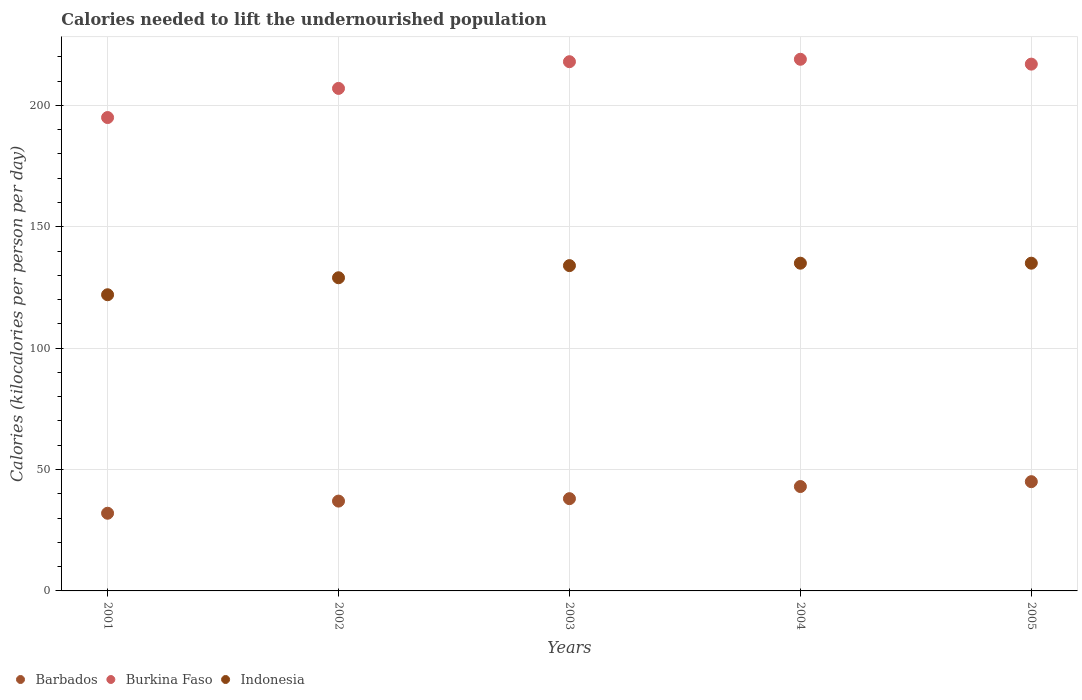Is the number of dotlines equal to the number of legend labels?
Give a very brief answer. Yes. What is the total calories needed to lift the undernourished population in Burkina Faso in 2001?
Provide a short and direct response. 195. Across all years, what is the maximum total calories needed to lift the undernourished population in Burkina Faso?
Offer a very short reply. 219. Across all years, what is the minimum total calories needed to lift the undernourished population in Burkina Faso?
Give a very brief answer. 195. What is the total total calories needed to lift the undernourished population in Indonesia in the graph?
Provide a succinct answer. 655. What is the difference between the total calories needed to lift the undernourished population in Burkina Faso in 2002 and that in 2005?
Make the answer very short. -10. What is the difference between the total calories needed to lift the undernourished population in Indonesia in 2002 and the total calories needed to lift the undernourished population in Barbados in 2005?
Keep it short and to the point. 84. What is the average total calories needed to lift the undernourished population in Barbados per year?
Keep it short and to the point. 39. In the year 2003, what is the difference between the total calories needed to lift the undernourished population in Barbados and total calories needed to lift the undernourished population in Indonesia?
Provide a succinct answer. -96. In how many years, is the total calories needed to lift the undernourished population in Indonesia greater than 60 kilocalories?
Give a very brief answer. 5. What is the ratio of the total calories needed to lift the undernourished population in Indonesia in 2003 to that in 2005?
Ensure brevity in your answer.  0.99. What is the difference between the highest and the second highest total calories needed to lift the undernourished population in Indonesia?
Make the answer very short. 0. What is the difference between the highest and the lowest total calories needed to lift the undernourished population in Indonesia?
Offer a very short reply. 13. Is it the case that in every year, the sum of the total calories needed to lift the undernourished population in Barbados and total calories needed to lift the undernourished population in Burkina Faso  is greater than the total calories needed to lift the undernourished population in Indonesia?
Your answer should be compact. Yes. Is the total calories needed to lift the undernourished population in Burkina Faso strictly greater than the total calories needed to lift the undernourished population in Barbados over the years?
Provide a succinct answer. Yes. Is the total calories needed to lift the undernourished population in Indonesia strictly less than the total calories needed to lift the undernourished population in Barbados over the years?
Offer a very short reply. No. How many dotlines are there?
Keep it short and to the point. 3. How many years are there in the graph?
Offer a terse response. 5. What is the difference between two consecutive major ticks on the Y-axis?
Your response must be concise. 50. Does the graph contain any zero values?
Your response must be concise. No. Does the graph contain grids?
Your answer should be compact. Yes. Where does the legend appear in the graph?
Provide a short and direct response. Bottom left. How are the legend labels stacked?
Make the answer very short. Horizontal. What is the title of the graph?
Offer a terse response. Calories needed to lift the undernourished population. What is the label or title of the X-axis?
Your response must be concise. Years. What is the label or title of the Y-axis?
Keep it short and to the point. Calories (kilocalories per person per day). What is the Calories (kilocalories per person per day) in Barbados in 2001?
Offer a terse response. 32. What is the Calories (kilocalories per person per day) of Burkina Faso in 2001?
Your answer should be very brief. 195. What is the Calories (kilocalories per person per day) of Indonesia in 2001?
Ensure brevity in your answer.  122. What is the Calories (kilocalories per person per day) of Burkina Faso in 2002?
Provide a short and direct response. 207. What is the Calories (kilocalories per person per day) in Indonesia in 2002?
Your answer should be very brief. 129. What is the Calories (kilocalories per person per day) of Barbados in 2003?
Make the answer very short. 38. What is the Calories (kilocalories per person per day) in Burkina Faso in 2003?
Your answer should be very brief. 218. What is the Calories (kilocalories per person per day) of Indonesia in 2003?
Provide a short and direct response. 134. What is the Calories (kilocalories per person per day) in Burkina Faso in 2004?
Your response must be concise. 219. What is the Calories (kilocalories per person per day) of Indonesia in 2004?
Your response must be concise. 135. What is the Calories (kilocalories per person per day) of Barbados in 2005?
Ensure brevity in your answer.  45. What is the Calories (kilocalories per person per day) of Burkina Faso in 2005?
Provide a succinct answer. 217. What is the Calories (kilocalories per person per day) in Indonesia in 2005?
Provide a short and direct response. 135. Across all years, what is the maximum Calories (kilocalories per person per day) in Barbados?
Make the answer very short. 45. Across all years, what is the maximum Calories (kilocalories per person per day) of Burkina Faso?
Your answer should be compact. 219. Across all years, what is the maximum Calories (kilocalories per person per day) of Indonesia?
Your answer should be very brief. 135. Across all years, what is the minimum Calories (kilocalories per person per day) in Burkina Faso?
Your answer should be compact. 195. Across all years, what is the minimum Calories (kilocalories per person per day) in Indonesia?
Offer a terse response. 122. What is the total Calories (kilocalories per person per day) in Barbados in the graph?
Make the answer very short. 195. What is the total Calories (kilocalories per person per day) of Burkina Faso in the graph?
Offer a terse response. 1056. What is the total Calories (kilocalories per person per day) in Indonesia in the graph?
Your response must be concise. 655. What is the difference between the Calories (kilocalories per person per day) of Burkina Faso in 2001 and that in 2002?
Your answer should be very brief. -12. What is the difference between the Calories (kilocalories per person per day) in Indonesia in 2001 and that in 2002?
Your answer should be compact. -7. What is the difference between the Calories (kilocalories per person per day) in Barbados in 2001 and that in 2003?
Offer a very short reply. -6. What is the difference between the Calories (kilocalories per person per day) of Indonesia in 2001 and that in 2003?
Keep it short and to the point. -12. What is the difference between the Calories (kilocalories per person per day) of Burkina Faso in 2001 and that in 2004?
Give a very brief answer. -24. What is the difference between the Calories (kilocalories per person per day) in Indonesia in 2001 and that in 2004?
Your answer should be very brief. -13. What is the difference between the Calories (kilocalories per person per day) of Indonesia in 2001 and that in 2005?
Provide a short and direct response. -13. What is the difference between the Calories (kilocalories per person per day) in Barbados in 2002 and that in 2003?
Your answer should be very brief. -1. What is the difference between the Calories (kilocalories per person per day) of Burkina Faso in 2002 and that in 2003?
Provide a short and direct response. -11. What is the difference between the Calories (kilocalories per person per day) in Indonesia in 2002 and that in 2003?
Your answer should be compact. -5. What is the difference between the Calories (kilocalories per person per day) of Indonesia in 2002 and that in 2004?
Keep it short and to the point. -6. What is the difference between the Calories (kilocalories per person per day) of Barbados in 2002 and that in 2005?
Ensure brevity in your answer.  -8. What is the difference between the Calories (kilocalories per person per day) in Indonesia in 2002 and that in 2005?
Keep it short and to the point. -6. What is the difference between the Calories (kilocalories per person per day) of Barbados in 2003 and that in 2004?
Your response must be concise. -5. What is the difference between the Calories (kilocalories per person per day) of Indonesia in 2003 and that in 2004?
Your response must be concise. -1. What is the difference between the Calories (kilocalories per person per day) of Barbados in 2004 and that in 2005?
Keep it short and to the point. -2. What is the difference between the Calories (kilocalories per person per day) in Indonesia in 2004 and that in 2005?
Offer a very short reply. 0. What is the difference between the Calories (kilocalories per person per day) of Barbados in 2001 and the Calories (kilocalories per person per day) of Burkina Faso in 2002?
Your answer should be very brief. -175. What is the difference between the Calories (kilocalories per person per day) in Barbados in 2001 and the Calories (kilocalories per person per day) in Indonesia in 2002?
Your response must be concise. -97. What is the difference between the Calories (kilocalories per person per day) of Barbados in 2001 and the Calories (kilocalories per person per day) of Burkina Faso in 2003?
Ensure brevity in your answer.  -186. What is the difference between the Calories (kilocalories per person per day) of Barbados in 2001 and the Calories (kilocalories per person per day) of Indonesia in 2003?
Give a very brief answer. -102. What is the difference between the Calories (kilocalories per person per day) of Barbados in 2001 and the Calories (kilocalories per person per day) of Burkina Faso in 2004?
Give a very brief answer. -187. What is the difference between the Calories (kilocalories per person per day) of Barbados in 2001 and the Calories (kilocalories per person per day) of Indonesia in 2004?
Ensure brevity in your answer.  -103. What is the difference between the Calories (kilocalories per person per day) in Burkina Faso in 2001 and the Calories (kilocalories per person per day) in Indonesia in 2004?
Give a very brief answer. 60. What is the difference between the Calories (kilocalories per person per day) of Barbados in 2001 and the Calories (kilocalories per person per day) of Burkina Faso in 2005?
Keep it short and to the point. -185. What is the difference between the Calories (kilocalories per person per day) of Barbados in 2001 and the Calories (kilocalories per person per day) of Indonesia in 2005?
Make the answer very short. -103. What is the difference between the Calories (kilocalories per person per day) of Burkina Faso in 2001 and the Calories (kilocalories per person per day) of Indonesia in 2005?
Ensure brevity in your answer.  60. What is the difference between the Calories (kilocalories per person per day) in Barbados in 2002 and the Calories (kilocalories per person per day) in Burkina Faso in 2003?
Your answer should be compact. -181. What is the difference between the Calories (kilocalories per person per day) of Barbados in 2002 and the Calories (kilocalories per person per day) of Indonesia in 2003?
Keep it short and to the point. -97. What is the difference between the Calories (kilocalories per person per day) of Burkina Faso in 2002 and the Calories (kilocalories per person per day) of Indonesia in 2003?
Your answer should be very brief. 73. What is the difference between the Calories (kilocalories per person per day) of Barbados in 2002 and the Calories (kilocalories per person per day) of Burkina Faso in 2004?
Ensure brevity in your answer.  -182. What is the difference between the Calories (kilocalories per person per day) in Barbados in 2002 and the Calories (kilocalories per person per day) in Indonesia in 2004?
Your answer should be very brief. -98. What is the difference between the Calories (kilocalories per person per day) in Barbados in 2002 and the Calories (kilocalories per person per day) in Burkina Faso in 2005?
Provide a succinct answer. -180. What is the difference between the Calories (kilocalories per person per day) in Barbados in 2002 and the Calories (kilocalories per person per day) in Indonesia in 2005?
Keep it short and to the point. -98. What is the difference between the Calories (kilocalories per person per day) of Barbados in 2003 and the Calories (kilocalories per person per day) of Burkina Faso in 2004?
Offer a very short reply. -181. What is the difference between the Calories (kilocalories per person per day) in Barbados in 2003 and the Calories (kilocalories per person per day) in Indonesia in 2004?
Provide a succinct answer. -97. What is the difference between the Calories (kilocalories per person per day) of Barbados in 2003 and the Calories (kilocalories per person per day) of Burkina Faso in 2005?
Your answer should be compact. -179. What is the difference between the Calories (kilocalories per person per day) in Barbados in 2003 and the Calories (kilocalories per person per day) in Indonesia in 2005?
Provide a succinct answer. -97. What is the difference between the Calories (kilocalories per person per day) in Burkina Faso in 2003 and the Calories (kilocalories per person per day) in Indonesia in 2005?
Keep it short and to the point. 83. What is the difference between the Calories (kilocalories per person per day) in Barbados in 2004 and the Calories (kilocalories per person per day) in Burkina Faso in 2005?
Provide a succinct answer. -174. What is the difference between the Calories (kilocalories per person per day) in Barbados in 2004 and the Calories (kilocalories per person per day) in Indonesia in 2005?
Provide a short and direct response. -92. What is the difference between the Calories (kilocalories per person per day) of Burkina Faso in 2004 and the Calories (kilocalories per person per day) of Indonesia in 2005?
Provide a short and direct response. 84. What is the average Calories (kilocalories per person per day) of Barbados per year?
Offer a very short reply. 39. What is the average Calories (kilocalories per person per day) of Burkina Faso per year?
Give a very brief answer. 211.2. What is the average Calories (kilocalories per person per day) in Indonesia per year?
Provide a short and direct response. 131. In the year 2001, what is the difference between the Calories (kilocalories per person per day) of Barbados and Calories (kilocalories per person per day) of Burkina Faso?
Offer a terse response. -163. In the year 2001, what is the difference between the Calories (kilocalories per person per day) of Barbados and Calories (kilocalories per person per day) of Indonesia?
Keep it short and to the point. -90. In the year 2001, what is the difference between the Calories (kilocalories per person per day) of Burkina Faso and Calories (kilocalories per person per day) of Indonesia?
Provide a succinct answer. 73. In the year 2002, what is the difference between the Calories (kilocalories per person per day) of Barbados and Calories (kilocalories per person per day) of Burkina Faso?
Offer a terse response. -170. In the year 2002, what is the difference between the Calories (kilocalories per person per day) in Barbados and Calories (kilocalories per person per day) in Indonesia?
Offer a terse response. -92. In the year 2003, what is the difference between the Calories (kilocalories per person per day) of Barbados and Calories (kilocalories per person per day) of Burkina Faso?
Ensure brevity in your answer.  -180. In the year 2003, what is the difference between the Calories (kilocalories per person per day) in Barbados and Calories (kilocalories per person per day) in Indonesia?
Offer a very short reply. -96. In the year 2003, what is the difference between the Calories (kilocalories per person per day) in Burkina Faso and Calories (kilocalories per person per day) in Indonesia?
Your answer should be compact. 84. In the year 2004, what is the difference between the Calories (kilocalories per person per day) in Barbados and Calories (kilocalories per person per day) in Burkina Faso?
Your response must be concise. -176. In the year 2004, what is the difference between the Calories (kilocalories per person per day) of Barbados and Calories (kilocalories per person per day) of Indonesia?
Offer a very short reply. -92. In the year 2005, what is the difference between the Calories (kilocalories per person per day) in Barbados and Calories (kilocalories per person per day) in Burkina Faso?
Ensure brevity in your answer.  -172. In the year 2005, what is the difference between the Calories (kilocalories per person per day) of Barbados and Calories (kilocalories per person per day) of Indonesia?
Keep it short and to the point. -90. What is the ratio of the Calories (kilocalories per person per day) in Barbados in 2001 to that in 2002?
Your answer should be compact. 0.86. What is the ratio of the Calories (kilocalories per person per day) in Burkina Faso in 2001 to that in 2002?
Provide a succinct answer. 0.94. What is the ratio of the Calories (kilocalories per person per day) of Indonesia in 2001 to that in 2002?
Offer a terse response. 0.95. What is the ratio of the Calories (kilocalories per person per day) of Barbados in 2001 to that in 2003?
Offer a terse response. 0.84. What is the ratio of the Calories (kilocalories per person per day) in Burkina Faso in 2001 to that in 2003?
Keep it short and to the point. 0.89. What is the ratio of the Calories (kilocalories per person per day) of Indonesia in 2001 to that in 2003?
Your answer should be very brief. 0.91. What is the ratio of the Calories (kilocalories per person per day) of Barbados in 2001 to that in 2004?
Give a very brief answer. 0.74. What is the ratio of the Calories (kilocalories per person per day) of Burkina Faso in 2001 to that in 2004?
Give a very brief answer. 0.89. What is the ratio of the Calories (kilocalories per person per day) of Indonesia in 2001 to that in 2004?
Provide a succinct answer. 0.9. What is the ratio of the Calories (kilocalories per person per day) in Barbados in 2001 to that in 2005?
Ensure brevity in your answer.  0.71. What is the ratio of the Calories (kilocalories per person per day) of Burkina Faso in 2001 to that in 2005?
Give a very brief answer. 0.9. What is the ratio of the Calories (kilocalories per person per day) in Indonesia in 2001 to that in 2005?
Keep it short and to the point. 0.9. What is the ratio of the Calories (kilocalories per person per day) of Barbados in 2002 to that in 2003?
Ensure brevity in your answer.  0.97. What is the ratio of the Calories (kilocalories per person per day) in Burkina Faso in 2002 to that in 2003?
Give a very brief answer. 0.95. What is the ratio of the Calories (kilocalories per person per day) in Indonesia in 2002 to that in 2003?
Make the answer very short. 0.96. What is the ratio of the Calories (kilocalories per person per day) of Barbados in 2002 to that in 2004?
Provide a succinct answer. 0.86. What is the ratio of the Calories (kilocalories per person per day) of Burkina Faso in 2002 to that in 2004?
Offer a very short reply. 0.95. What is the ratio of the Calories (kilocalories per person per day) of Indonesia in 2002 to that in 2004?
Keep it short and to the point. 0.96. What is the ratio of the Calories (kilocalories per person per day) of Barbados in 2002 to that in 2005?
Offer a terse response. 0.82. What is the ratio of the Calories (kilocalories per person per day) in Burkina Faso in 2002 to that in 2005?
Provide a short and direct response. 0.95. What is the ratio of the Calories (kilocalories per person per day) in Indonesia in 2002 to that in 2005?
Your answer should be compact. 0.96. What is the ratio of the Calories (kilocalories per person per day) in Barbados in 2003 to that in 2004?
Keep it short and to the point. 0.88. What is the ratio of the Calories (kilocalories per person per day) of Indonesia in 2003 to that in 2004?
Offer a terse response. 0.99. What is the ratio of the Calories (kilocalories per person per day) of Barbados in 2003 to that in 2005?
Provide a succinct answer. 0.84. What is the ratio of the Calories (kilocalories per person per day) in Burkina Faso in 2003 to that in 2005?
Offer a very short reply. 1. What is the ratio of the Calories (kilocalories per person per day) of Indonesia in 2003 to that in 2005?
Offer a very short reply. 0.99. What is the ratio of the Calories (kilocalories per person per day) of Barbados in 2004 to that in 2005?
Your answer should be very brief. 0.96. What is the ratio of the Calories (kilocalories per person per day) in Burkina Faso in 2004 to that in 2005?
Give a very brief answer. 1.01. What is the ratio of the Calories (kilocalories per person per day) of Indonesia in 2004 to that in 2005?
Make the answer very short. 1. What is the difference between the highest and the lowest Calories (kilocalories per person per day) in Barbados?
Keep it short and to the point. 13. What is the difference between the highest and the lowest Calories (kilocalories per person per day) in Burkina Faso?
Your response must be concise. 24. 